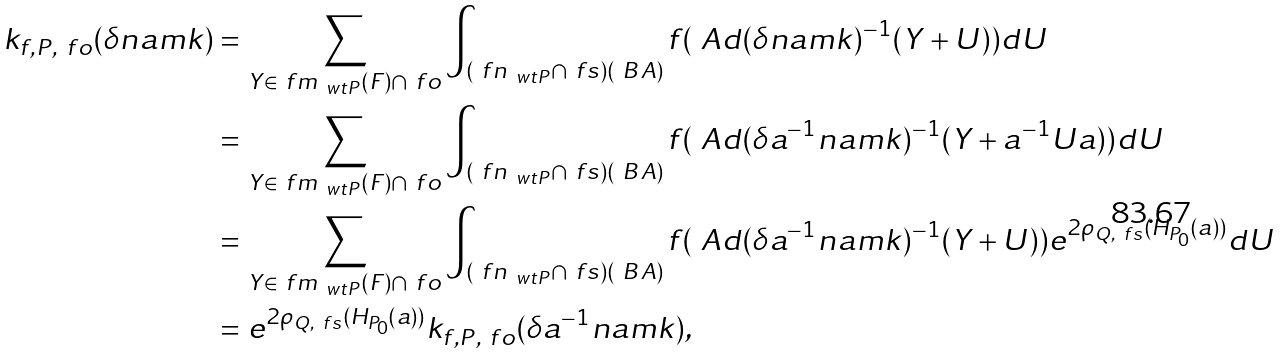Convert formula to latex. <formula><loc_0><loc_0><loc_500><loc_500>k _ { f , P , \ f o } ( \delta n a m k ) & = \sum _ { Y \in \ f m _ { \ w t { P } } ( F ) \cap \ f o } \int _ { ( \ f n _ { \ w t { P } } \cap \ f s ) ( \ B A ) } f ( \ A d ( \delta n a m k ) ^ { - 1 } ( Y + U ) ) d U \\ & = \sum _ { Y \in \ f m _ { \ w t { P } } ( F ) \cap \ f o } \int _ { ( \ f n _ { \ w t { P } } \cap \ f s ) ( \ B A ) } f ( \ A d ( \delta a ^ { - 1 } n a m k ) ^ { - 1 } ( Y + a ^ { - 1 } U a ) ) d U \\ & = \sum _ { Y \in \ f m _ { \ w t { P } } ( F ) \cap \ f o } \int _ { ( \ f n _ { \ w t { P } } \cap \ f s ) ( \ B A ) } f ( \ A d ( \delta a ^ { - 1 } n a m k ) ^ { - 1 } ( Y + U ) ) e ^ { 2 \rho _ { Q , \ f s } ( H _ { P _ { 0 } } ( a ) ) } d U \\ & = e ^ { 2 \rho _ { Q , \ f s } ( H _ { P _ { 0 } } ( a ) ) } k _ { f , P , \ f o } ( \delta a ^ { - 1 } n a m k ) ,</formula> 